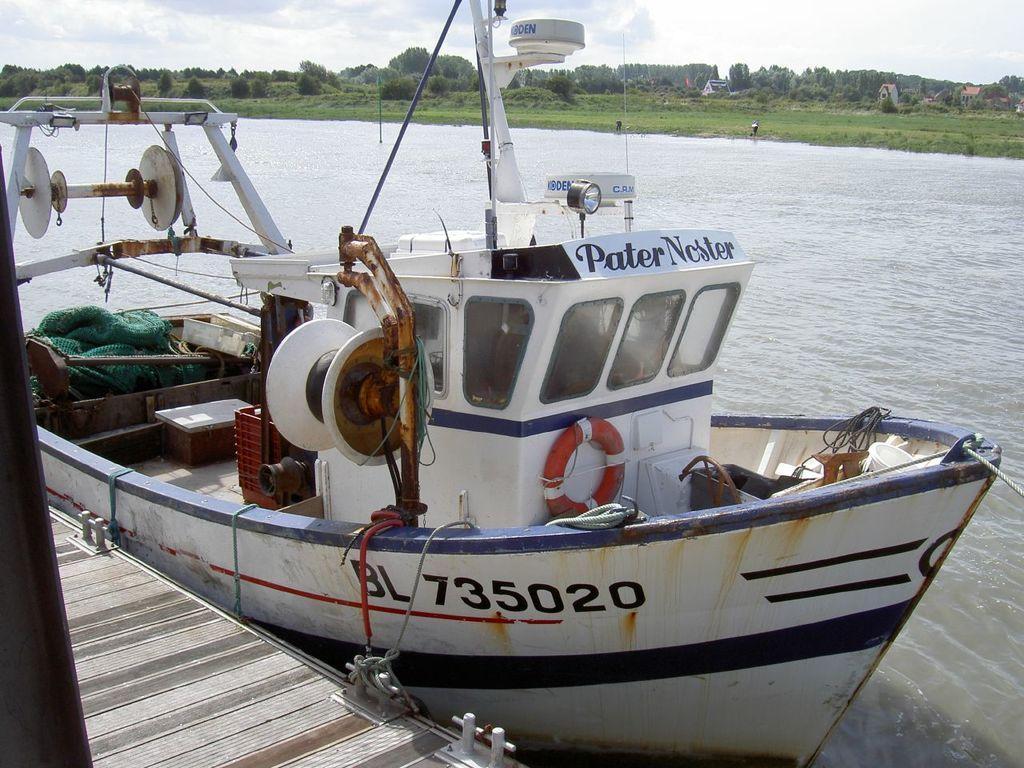Please provide a concise description of this image. There is a boat with windows and something is written on the boat. There is a tube, poles, net and many other things in the boat. And it is tied with a rope to the deck. And the boat is on the water. In the back there is grass, trees and sky. 